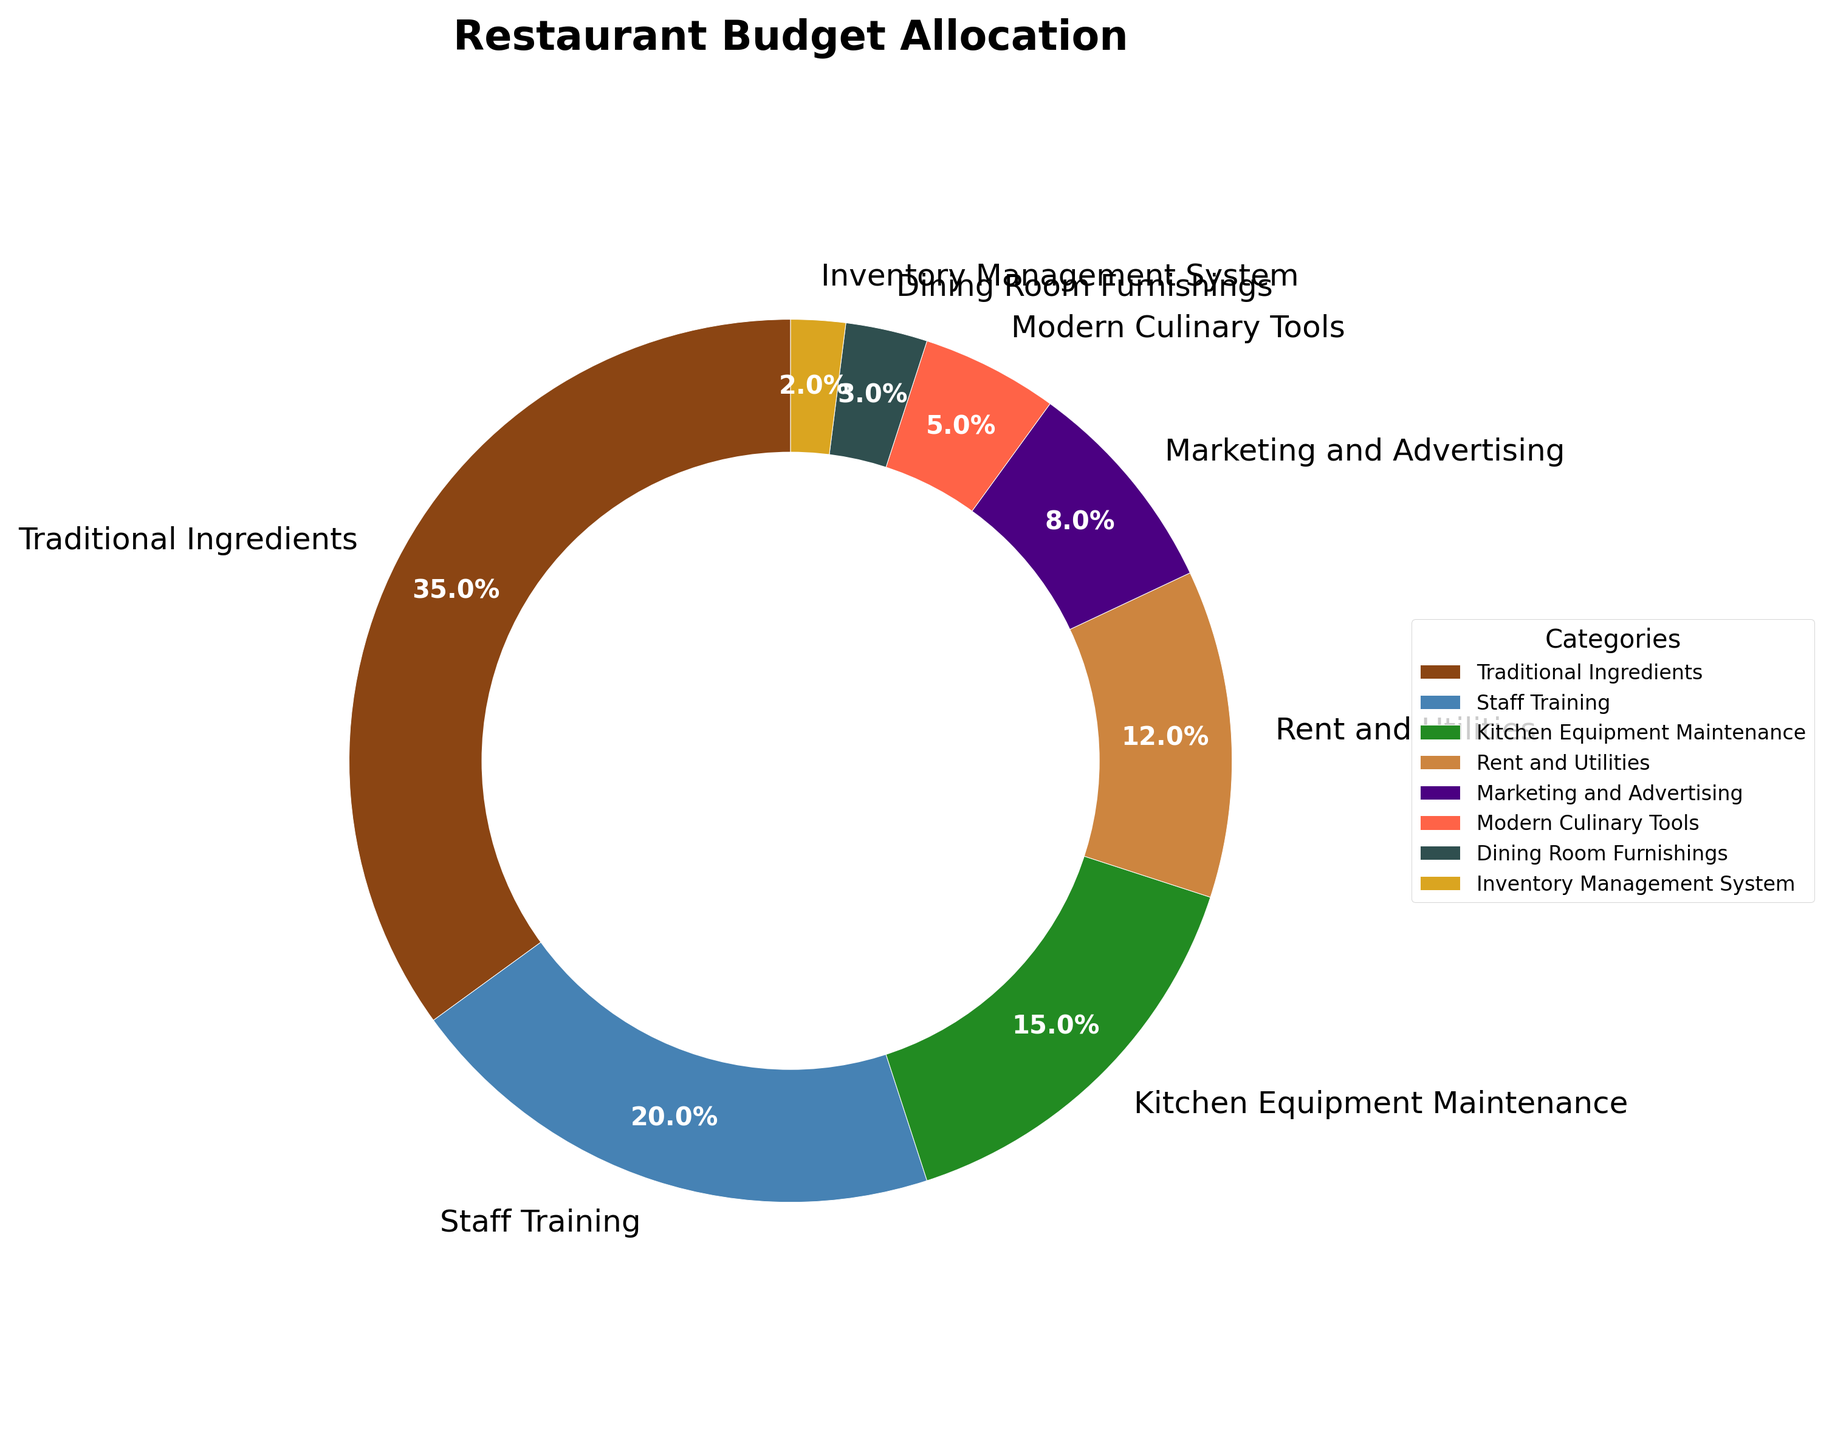What percentage of the budget is allocated to traditional ingredients? Looking at the figure, we locate the slice labeled "Traditional Ingredients" and note its percentage.
Answer: 35% How much more is allocated to staff training compared to the inventory management system? The percentage for staff training is 20%, and for the inventory management system, it is 2%. The difference between them is 20% - 2% = 18%.
Answer: 18% Which category receives the least amount of the budget? Observing the figure, the smallest slice corresponds to the "Inventory Management System" with 2%.
Answer: Inventory Management System How much of the budget is spent on kitchen-related expenses (Traditional Ingredients, Kitchen Equipment Maintenance, Modern Culinary Tools)? Adding the percentages for Traditional Ingredients (35%), Kitchen Equipment Maintenance (15%), and Modern Culinary Tools (5%) results in 35% + 15% + 5% = 55%.
Answer: 55% What is the combined percentage for rent and utilities, and marketing and advertising? Summing the percentages for Rent and Utilities (12%) and Marketing and Advertising (8%) yields 12% + 8% = 20%.
Answer: 20% What is the difference in budget allocation between dining room furnishings and modern culinary tools? The percentage for Dining Room Furnishings is 3%, and for Modern Culinary Tools, it is 5%. The difference is 5% - 3% = 2%.
Answer: 2% Which category has a larger budget allocation, staff training or kitchen equipment maintenance? Comparing the percentages, staff training has 20%, and kitchen equipment maintenance has 15%. Staff training has a larger allocation.
Answer: Staff Training How much is allocated to marketing and advertising in comparison to dining room furnishings and inventory management systems combined? The percentage for Marketing and Advertising is 8%, while the combined percentage for Dining Room Furnishings (3%) and Inventory Management System (2%) is 3% + 2% = 5%. Hence, marketing and advertising is larger by 8% - 5% = 3%.
Answer: 3% What percentage of the budget is allocated to all categories other than traditional ingredients? Subtract the percentage for Traditional Ingredients (35%) from 100% to get the remaining allocation: 100% - 35% = 65%.
Answer: 65% Is more of the budget spent on rent and utilities or marketing and advertising? Comparing their percentages, rent and utilities have 12%, whereas marketing and advertising have 8%. Rent and utilities have a higher allocation.
Answer: Rent and Utilities 